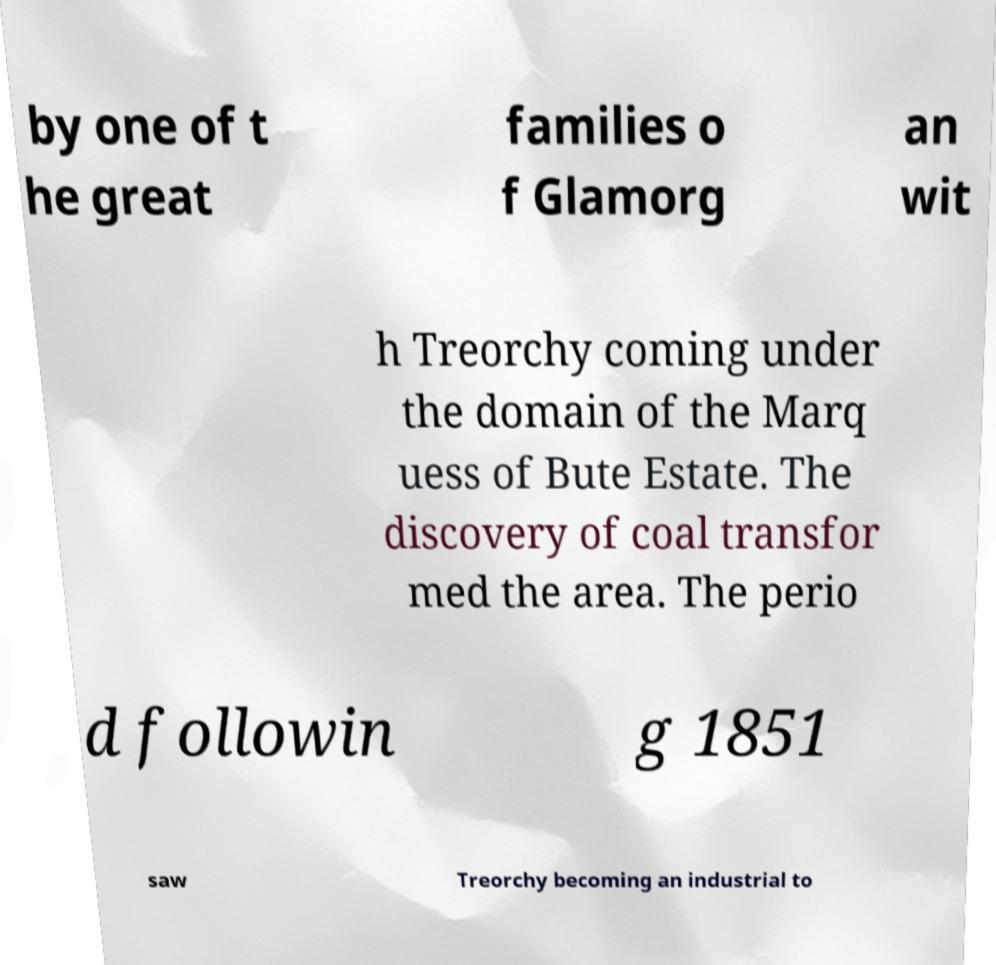Can you accurately transcribe the text from the provided image for me? by one of t he great families o f Glamorg an wit h Treorchy coming under the domain of the Marq uess of Bute Estate. The discovery of coal transfor med the area. The perio d followin g 1851 saw Treorchy becoming an industrial to 